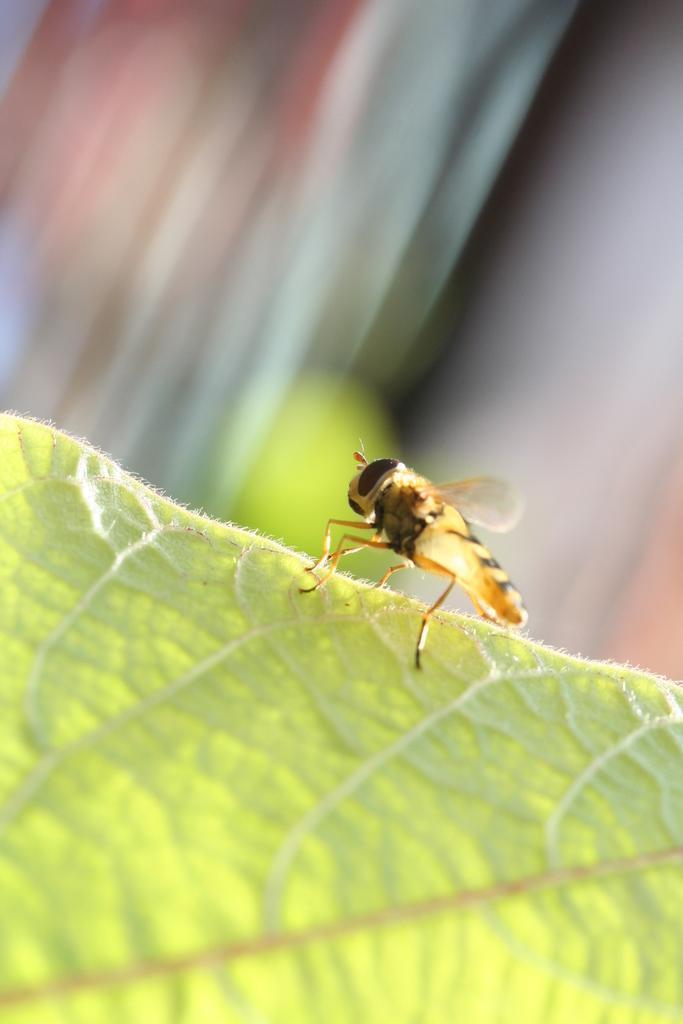Describe this image in one or two sentences. In this image I can see a insect which is in yellow and black color. The insect is on green leaf. Background is blurred. 